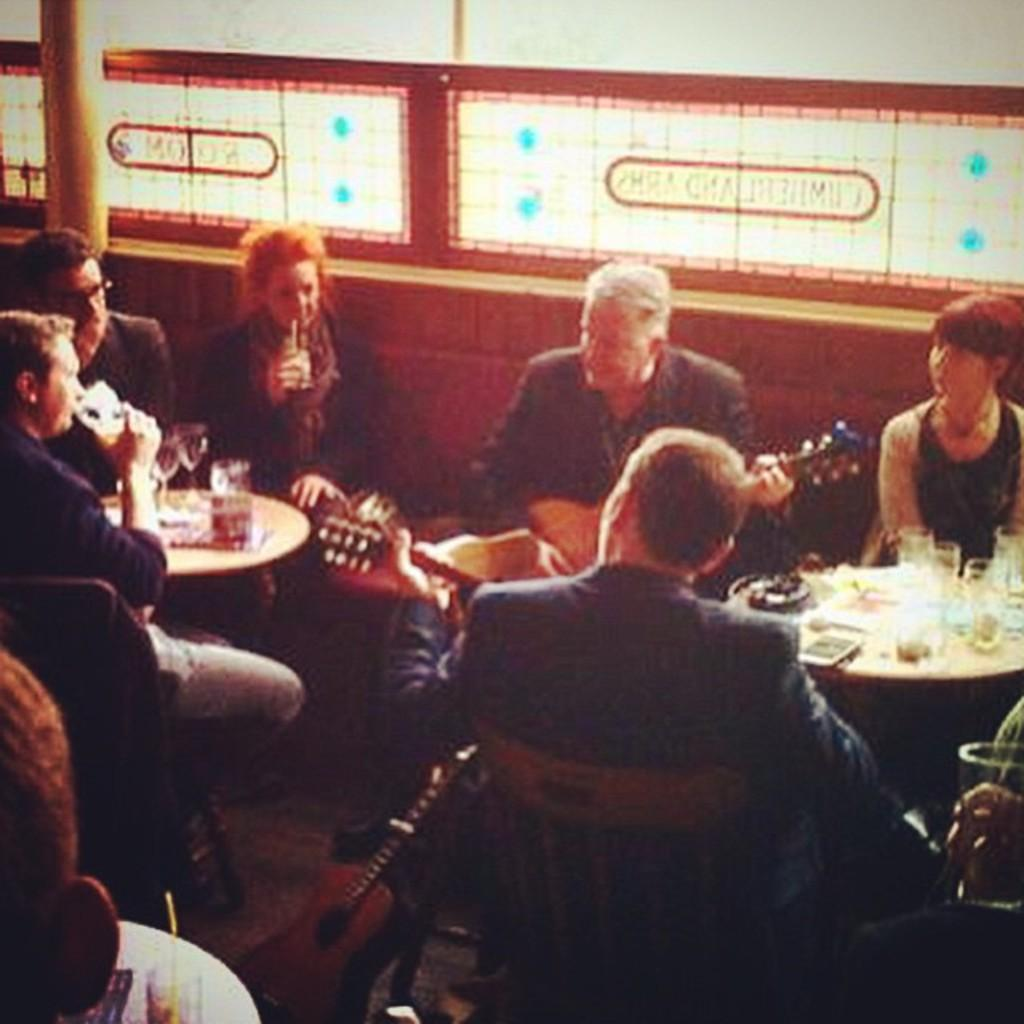What are the people in the image doing? The people in the image are sitting on chairs. What are some of the people holding in the image? Some people are holding guitars in the image. What objects can be seen on the table in the image? There are glasses on a table in the image. What type of action can be seen cracking the coal in the image? There is no action, cracking, or coal present in the image. 